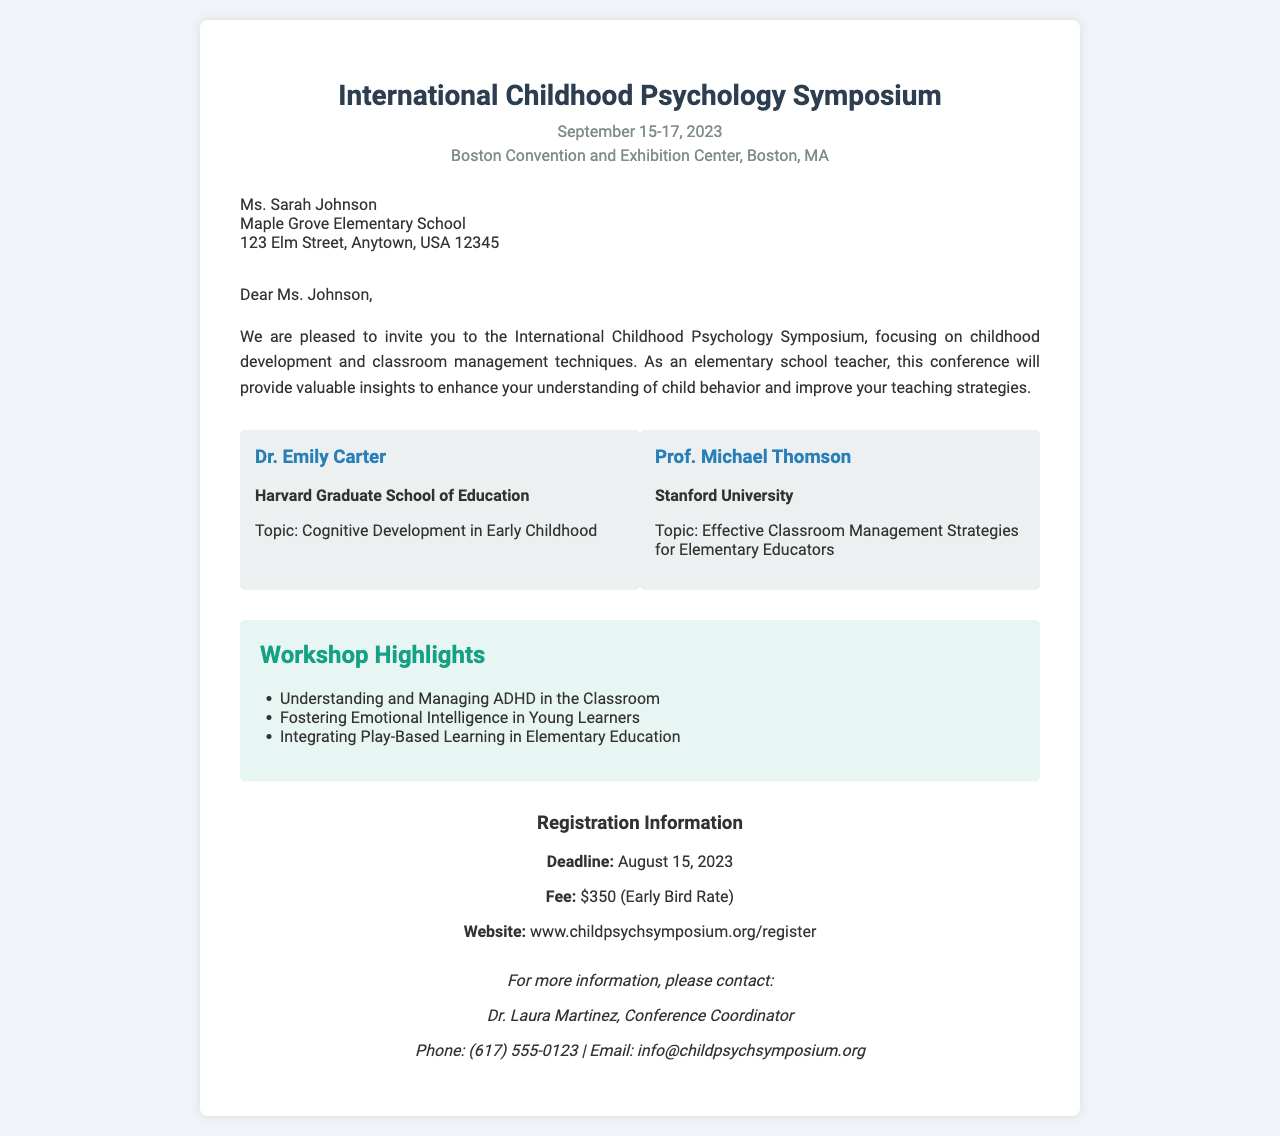What are the dates of the symposium? The dates, as mentioned in the document, are September 15-17, 2023.
Answer: September 15-17, 2023 Who is invited to the conference? The recipient of the invitation is Ms. Sarah Johnson, an elementary school teacher.
Answer: Ms. Sarah Johnson What is the location of the symposium? The document states that the location is the Boston Convention and Exhibition Center, Boston, MA.
Answer: Boston Convention and Exhibition Center, Boston, MA What is the early bird registration fee? The early bird registration fee mentioned in the document is $350.
Answer: $350 Who is one of the speakers and what is their topic? The document lists Dr. Emily Carter and her topic, Cognitive Development in Early Childhood.
Answer: Dr. Emily Carter, Cognitive Development in Early Childhood What is one of the workshop highlights? The document highlights "Understanding and Managing ADHD in the Classroom" as one of the workshops.
Answer: Understanding and Managing ADHD in the Classroom When is the registration deadline? According to the document, the registration deadline is August 15, 2023.
Answer: August 15, 2023 What is the contact person's name? The contact person listed in the document is Dr. Laura Martinez.
Answer: Dr. Laura Martinez Which university is Prof. Michael Thomson affiliated with? The document indicates that Prof. Michael Thomson is affiliated with Stanford University.
Answer: Stanford University 